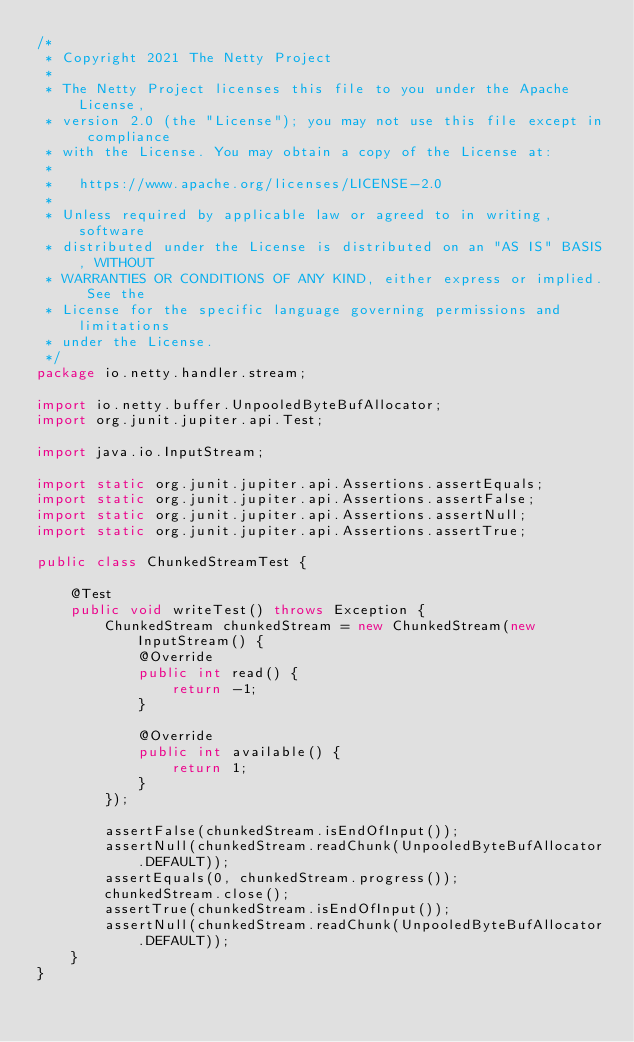<code> <loc_0><loc_0><loc_500><loc_500><_Java_>/*
 * Copyright 2021 The Netty Project
 *
 * The Netty Project licenses this file to you under the Apache License,
 * version 2.0 (the "License"); you may not use this file except in compliance
 * with the License. You may obtain a copy of the License at:
 *
 *   https://www.apache.org/licenses/LICENSE-2.0
 *
 * Unless required by applicable law or agreed to in writing, software
 * distributed under the License is distributed on an "AS IS" BASIS, WITHOUT
 * WARRANTIES OR CONDITIONS OF ANY KIND, either express or implied. See the
 * License for the specific language governing permissions and limitations
 * under the License.
 */
package io.netty.handler.stream;

import io.netty.buffer.UnpooledByteBufAllocator;
import org.junit.jupiter.api.Test;

import java.io.InputStream;

import static org.junit.jupiter.api.Assertions.assertEquals;
import static org.junit.jupiter.api.Assertions.assertFalse;
import static org.junit.jupiter.api.Assertions.assertNull;
import static org.junit.jupiter.api.Assertions.assertTrue;

public class ChunkedStreamTest {

    @Test
    public void writeTest() throws Exception {
        ChunkedStream chunkedStream = new ChunkedStream(new InputStream() {
            @Override
            public int read() {
                return -1;
            }

            @Override
            public int available() {
                return 1;
            }
        });

        assertFalse(chunkedStream.isEndOfInput());
        assertNull(chunkedStream.readChunk(UnpooledByteBufAllocator.DEFAULT));
        assertEquals(0, chunkedStream.progress());
        chunkedStream.close();
        assertTrue(chunkedStream.isEndOfInput());
        assertNull(chunkedStream.readChunk(UnpooledByteBufAllocator.DEFAULT));
    }
}
</code> 